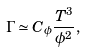<formula> <loc_0><loc_0><loc_500><loc_500>\Gamma \simeq C _ { \phi } \frac { T ^ { 3 } } { \phi ^ { 2 } } ,</formula> 